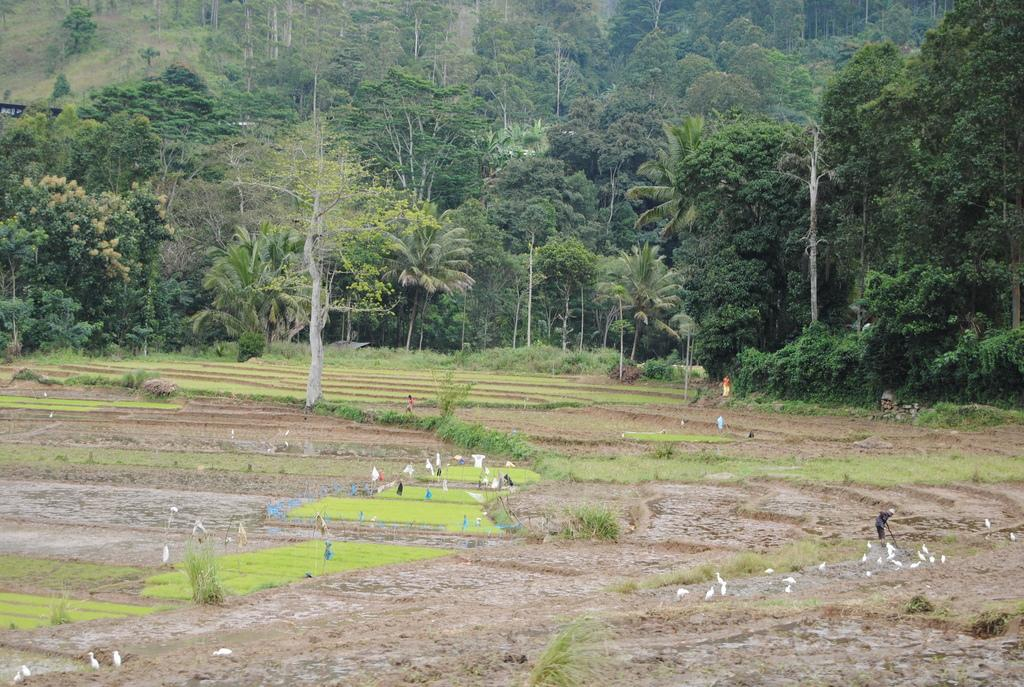What is the main subject in the middle of the image? There is a farm in the middle of the image. What can be seen at the top of the image? There are trees at the top of the image. What type of animals are on the ground in the image? There are white birds on the ground in the image. How many degrees are required to complete the curve in the image? There is no curve present in the image, so the number of degrees required cannot be determined. 